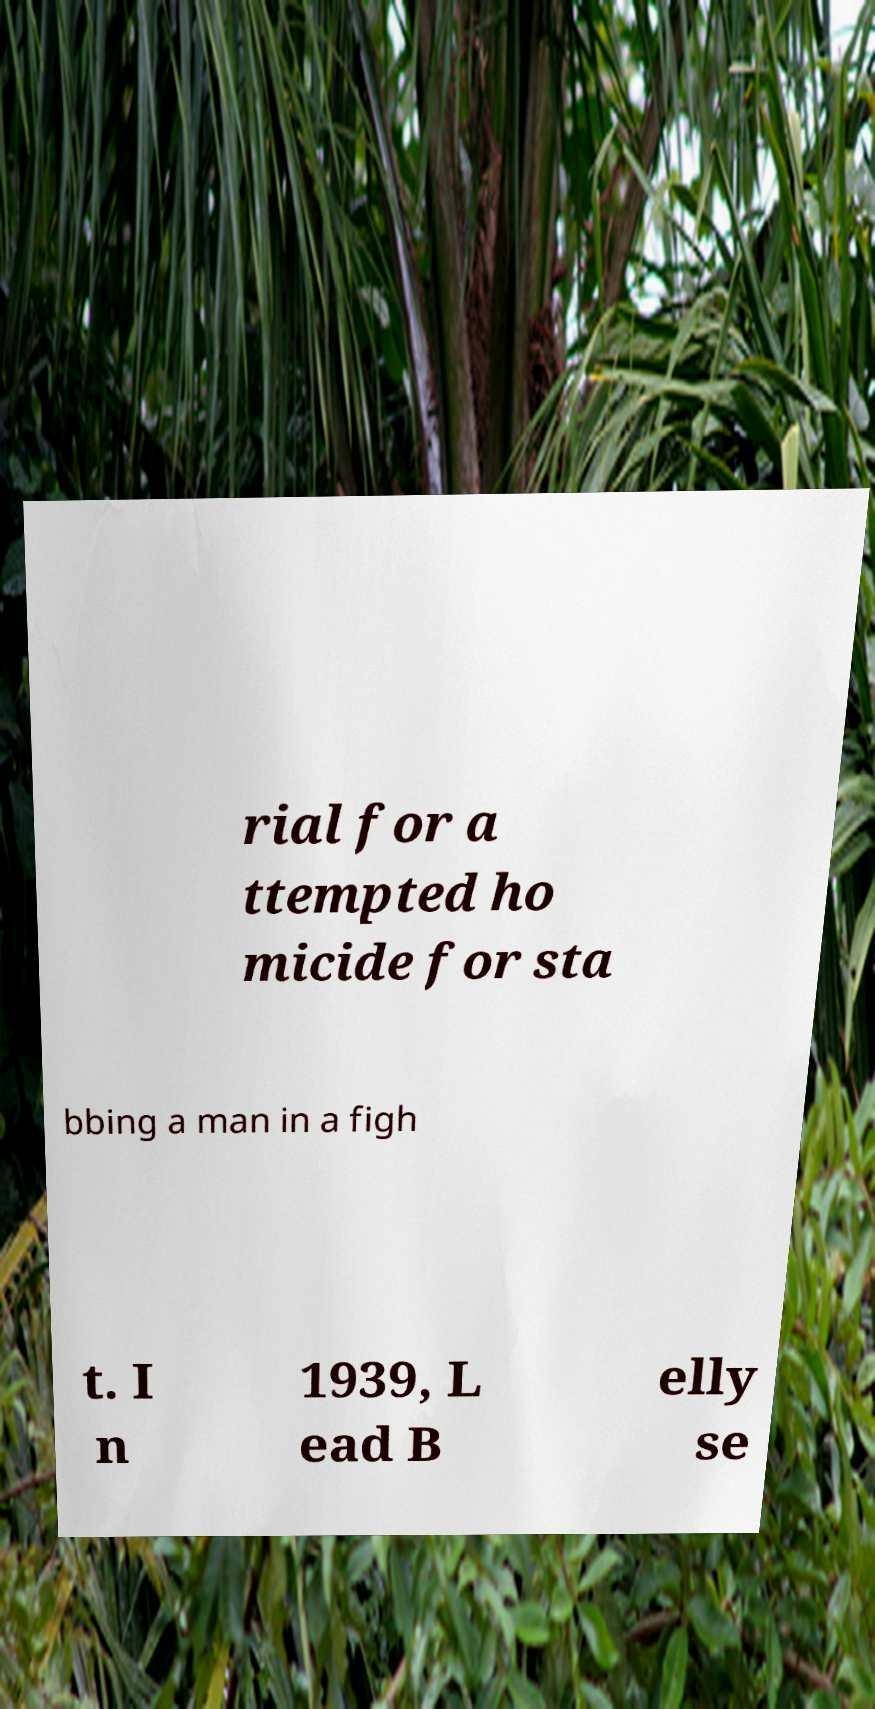Can you accurately transcribe the text from the provided image for me? rial for a ttempted ho micide for sta bbing a man in a figh t. I n 1939, L ead B elly se 